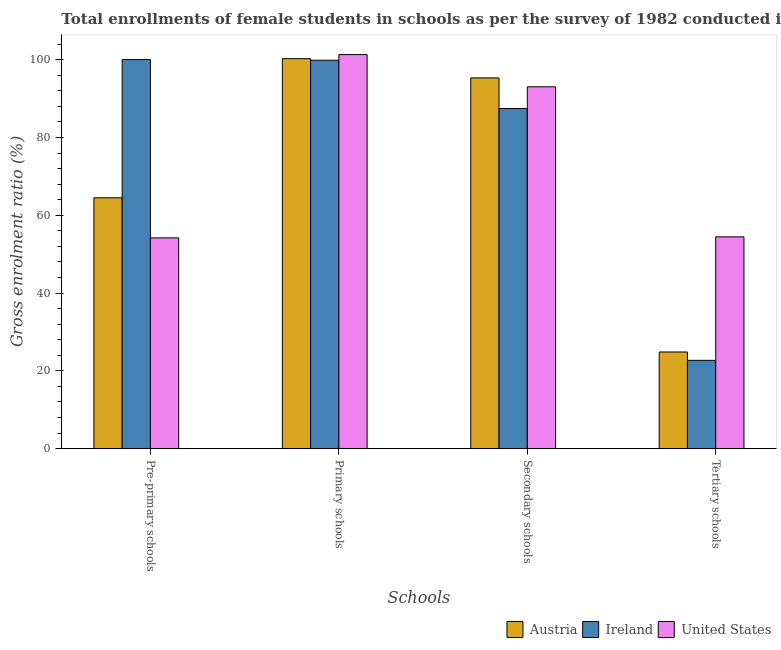How many different coloured bars are there?
Offer a very short reply. 3. How many groups of bars are there?
Your response must be concise. 4. How many bars are there on the 3rd tick from the left?
Your response must be concise. 3. How many bars are there on the 3rd tick from the right?
Ensure brevity in your answer.  3. What is the label of the 1st group of bars from the left?
Offer a very short reply. Pre-primary schools. What is the gross enrolment ratio(female) in tertiary schools in Ireland?
Offer a very short reply. 22.71. Across all countries, what is the maximum gross enrolment ratio(female) in secondary schools?
Provide a short and direct response. 95.3. Across all countries, what is the minimum gross enrolment ratio(female) in secondary schools?
Offer a very short reply. 87.44. In which country was the gross enrolment ratio(female) in primary schools maximum?
Your answer should be very brief. United States. In which country was the gross enrolment ratio(female) in tertiary schools minimum?
Your response must be concise. Ireland. What is the total gross enrolment ratio(female) in pre-primary schools in the graph?
Keep it short and to the point. 218.69. What is the difference between the gross enrolment ratio(female) in primary schools in Austria and that in Ireland?
Provide a succinct answer. 0.41. What is the difference between the gross enrolment ratio(female) in primary schools in Ireland and the gross enrolment ratio(female) in pre-primary schools in United States?
Your response must be concise. 45.66. What is the average gross enrolment ratio(female) in pre-primary schools per country?
Provide a short and direct response. 72.9. What is the difference between the gross enrolment ratio(female) in pre-primary schools and gross enrolment ratio(female) in secondary schools in United States?
Ensure brevity in your answer.  -38.84. What is the ratio of the gross enrolment ratio(female) in secondary schools in Ireland to that in Austria?
Your answer should be compact. 0.92. Is the gross enrolment ratio(female) in secondary schools in Ireland less than that in United States?
Offer a terse response. Yes. What is the difference between the highest and the second highest gross enrolment ratio(female) in pre-primary schools?
Ensure brevity in your answer.  35.52. What is the difference between the highest and the lowest gross enrolment ratio(female) in primary schools?
Offer a very short reply. 1.46. Is the sum of the gross enrolment ratio(female) in pre-primary schools in Austria and United States greater than the maximum gross enrolment ratio(female) in tertiary schools across all countries?
Provide a succinct answer. Yes. What does the 2nd bar from the left in Tertiary schools represents?
Provide a succinct answer. Ireland. What does the 1st bar from the right in Secondary schools represents?
Your answer should be compact. United States. Where does the legend appear in the graph?
Give a very brief answer. Bottom right. How many legend labels are there?
Give a very brief answer. 3. How are the legend labels stacked?
Make the answer very short. Horizontal. What is the title of the graph?
Your answer should be very brief. Total enrollments of female students in schools as per the survey of 1982 conducted in different countries. Does "Benin" appear as one of the legend labels in the graph?
Ensure brevity in your answer.  No. What is the label or title of the X-axis?
Offer a very short reply. Schools. What is the Gross enrolment ratio (%) of Austria in Pre-primary schools?
Give a very brief answer. 64.49. What is the Gross enrolment ratio (%) in Ireland in Pre-primary schools?
Your answer should be compact. 100.01. What is the Gross enrolment ratio (%) of United States in Pre-primary schools?
Offer a terse response. 54.18. What is the Gross enrolment ratio (%) of Austria in Primary schools?
Provide a short and direct response. 100.24. What is the Gross enrolment ratio (%) in Ireland in Primary schools?
Offer a terse response. 99.84. What is the Gross enrolment ratio (%) in United States in Primary schools?
Ensure brevity in your answer.  101.3. What is the Gross enrolment ratio (%) in Austria in Secondary schools?
Provide a succinct answer. 95.3. What is the Gross enrolment ratio (%) of Ireland in Secondary schools?
Offer a very short reply. 87.44. What is the Gross enrolment ratio (%) of United States in Secondary schools?
Provide a short and direct response. 93.02. What is the Gross enrolment ratio (%) of Austria in Tertiary schools?
Your answer should be very brief. 24.85. What is the Gross enrolment ratio (%) of Ireland in Tertiary schools?
Make the answer very short. 22.71. What is the Gross enrolment ratio (%) in United States in Tertiary schools?
Your answer should be compact. 54.45. Across all Schools, what is the maximum Gross enrolment ratio (%) of Austria?
Keep it short and to the point. 100.24. Across all Schools, what is the maximum Gross enrolment ratio (%) in Ireland?
Make the answer very short. 100.01. Across all Schools, what is the maximum Gross enrolment ratio (%) of United States?
Make the answer very short. 101.3. Across all Schools, what is the minimum Gross enrolment ratio (%) in Austria?
Your answer should be compact. 24.85. Across all Schools, what is the minimum Gross enrolment ratio (%) of Ireland?
Your response must be concise. 22.71. Across all Schools, what is the minimum Gross enrolment ratio (%) in United States?
Keep it short and to the point. 54.18. What is the total Gross enrolment ratio (%) of Austria in the graph?
Make the answer very short. 284.89. What is the total Gross enrolment ratio (%) in Ireland in the graph?
Your answer should be very brief. 310. What is the total Gross enrolment ratio (%) of United States in the graph?
Provide a succinct answer. 302.95. What is the difference between the Gross enrolment ratio (%) of Austria in Pre-primary schools and that in Primary schools?
Offer a terse response. -35.75. What is the difference between the Gross enrolment ratio (%) in Ireland in Pre-primary schools and that in Primary schools?
Your response must be concise. 0.17. What is the difference between the Gross enrolment ratio (%) in United States in Pre-primary schools and that in Primary schools?
Keep it short and to the point. -47.12. What is the difference between the Gross enrolment ratio (%) in Austria in Pre-primary schools and that in Secondary schools?
Provide a succinct answer. -30.81. What is the difference between the Gross enrolment ratio (%) of Ireland in Pre-primary schools and that in Secondary schools?
Ensure brevity in your answer.  12.57. What is the difference between the Gross enrolment ratio (%) in United States in Pre-primary schools and that in Secondary schools?
Your response must be concise. -38.84. What is the difference between the Gross enrolment ratio (%) in Austria in Pre-primary schools and that in Tertiary schools?
Keep it short and to the point. 39.64. What is the difference between the Gross enrolment ratio (%) of Ireland in Pre-primary schools and that in Tertiary schools?
Offer a terse response. 77.31. What is the difference between the Gross enrolment ratio (%) of United States in Pre-primary schools and that in Tertiary schools?
Make the answer very short. -0.27. What is the difference between the Gross enrolment ratio (%) in Austria in Primary schools and that in Secondary schools?
Keep it short and to the point. 4.94. What is the difference between the Gross enrolment ratio (%) of Ireland in Primary schools and that in Secondary schools?
Give a very brief answer. 12.4. What is the difference between the Gross enrolment ratio (%) of United States in Primary schools and that in Secondary schools?
Your response must be concise. 8.28. What is the difference between the Gross enrolment ratio (%) in Austria in Primary schools and that in Tertiary schools?
Offer a very short reply. 75.39. What is the difference between the Gross enrolment ratio (%) in Ireland in Primary schools and that in Tertiary schools?
Give a very brief answer. 77.13. What is the difference between the Gross enrolment ratio (%) of United States in Primary schools and that in Tertiary schools?
Ensure brevity in your answer.  46.85. What is the difference between the Gross enrolment ratio (%) of Austria in Secondary schools and that in Tertiary schools?
Your response must be concise. 70.45. What is the difference between the Gross enrolment ratio (%) in Ireland in Secondary schools and that in Tertiary schools?
Ensure brevity in your answer.  64.73. What is the difference between the Gross enrolment ratio (%) in United States in Secondary schools and that in Tertiary schools?
Make the answer very short. 38.57. What is the difference between the Gross enrolment ratio (%) of Austria in Pre-primary schools and the Gross enrolment ratio (%) of Ireland in Primary schools?
Offer a very short reply. -35.35. What is the difference between the Gross enrolment ratio (%) in Austria in Pre-primary schools and the Gross enrolment ratio (%) in United States in Primary schools?
Your answer should be very brief. -36.81. What is the difference between the Gross enrolment ratio (%) in Ireland in Pre-primary schools and the Gross enrolment ratio (%) in United States in Primary schools?
Offer a very short reply. -1.29. What is the difference between the Gross enrolment ratio (%) of Austria in Pre-primary schools and the Gross enrolment ratio (%) of Ireland in Secondary schools?
Provide a short and direct response. -22.95. What is the difference between the Gross enrolment ratio (%) of Austria in Pre-primary schools and the Gross enrolment ratio (%) of United States in Secondary schools?
Make the answer very short. -28.53. What is the difference between the Gross enrolment ratio (%) of Ireland in Pre-primary schools and the Gross enrolment ratio (%) of United States in Secondary schools?
Give a very brief answer. 6.99. What is the difference between the Gross enrolment ratio (%) of Austria in Pre-primary schools and the Gross enrolment ratio (%) of Ireland in Tertiary schools?
Your answer should be compact. 41.78. What is the difference between the Gross enrolment ratio (%) in Austria in Pre-primary schools and the Gross enrolment ratio (%) in United States in Tertiary schools?
Give a very brief answer. 10.04. What is the difference between the Gross enrolment ratio (%) of Ireland in Pre-primary schools and the Gross enrolment ratio (%) of United States in Tertiary schools?
Offer a terse response. 45.57. What is the difference between the Gross enrolment ratio (%) in Austria in Primary schools and the Gross enrolment ratio (%) in Ireland in Secondary schools?
Offer a very short reply. 12.8. What is the difference between the Gross enrolment ratio (%) in Austria in Primary schools and the Gross enrolment ratio (%) in United States in Secondary schools?
Your response must be concise. 7.22. What is the difference between the Gross enrolment ratio (%) of Ireland in Primary schools and the Gross enrolment ratio (%) of United States in Secondary schools?
Give a very brief answer. 6.82. What is the difference between the Gross enrolment ratio (%) of Austria in Primary schools and the Gross enrolment ratio (%) of Ireland in Tertiary schools?
Offer a terse response. 77.54. What is the difference between the Gross enrolment ratio (%) in Austria in Primary schools and the Gross enrolment ratio (%) in United States in Tertiary schools?
Offer a terse response. 45.8. What is the difference between the Gross enrolment ratio (%) of Ireland in Primary schools and the Gross enrolment ratio (%) of United States in Tertiary schools?
Give a very brief answer. 45.39. What is the difference between the Gross enrolment ratio (%) of Austria in Secondary schools and the Gross enrolment ratio (%) of Ireland in Tertiary schools?
Give a very brief answer. 72.59. What is the difference between the Gross enrolment ratio (%) of Austria in Secondary schools and the Gross enrolment ratio (%) of United States in Tertiary schools?
Keep it short and to the point. 40.86. What is the difference between the Gross enrolment ratio (%) of Ireland in Secondary schools and the Gross enrolment ratio (%) of United States in Tertiary schools?
Provide a short and direct response. 32.99. What is the average Gross enrolment ratio (%) of Austria per Schools?
Give a very brief answer. 71.22. What is the average Gross enrolment ratio (%) of Ireland per Schools?
Provide a short and direct response. 77.5. What is the average Gross enrolment ratio (%) in United States per Schools?
Offer a terse response. 75.74. What is the difference between the Gross enrolment ratio (%) of Austria and Gross enrolment ratio (%) of Ireland in Pre-primary schools?
Your answer should be compact. -35.52. What is the difference between the Gross enrolment ratio (%) of Austria and Gross enrolment ratio (%) of United States in Pre-primary schools?
Keep it short and to the point. 10.31. What is the difference between the Gross enrolment ratio (%) of Ireland and Gross enrolment ratio (%) of United States in Pre-primary schools?
Offer a very short reply. 45.83. What is the difference between the Gross enrolment ratio (%) in Austria and Gross enrolment ratio (%) in Ireland in Primary schools?
Provide a succinct answer. 0.41. What is the difference between the Gross enrolment ratio (%) of Austria and Gross enrolment ratio (%) of United States in Primary schools?
Keep it short and to the point. -1.06. What is the difference between the Gross enrolment ratio (%) of Ireland and Gross enrolment ratio (%) of United States in Primary schools?
Offer a terse response. -1.46. What is the difference between the Gross enrolment ratio (%) in Austria and Gross enrolment ratio (%) in Ireland in Secondary schools?
Keep it short and to the point. 7.86. What is the difference between the Gross enrolment ratio (%) in Austria and Gross enrolment ratio (%) in United States in Secondary schools?
Make the answer very short. 2.28. What is the difference between the Gross enrolment ratio (%) of Ireland and Gross enrolment ratio (%) of United States in Secondary schools?
Provide a succinct answer. -5.58. What is the difference between the Gross enrolment ratio (%) of Austria and Gross enrolment ratio (%) of Ireland in Tertiary schools?
Give a very brief answer. 2.15. What is the difference between the Gross enrolment ratio (%) of Austria and Gross enrolment ratio (%) of United States in Tertiary schools?
Offer a terse response. -29.59. What is the difference between the Gross enrolment ratio (%) in Ireland and Gross enrolment ratio (%) in United States in Tertiary schools?
Ensure brevity in your answer.  -31.74. What is the ratio of the Gross enrolment ratio (%) in Austria in Pre-primary schools to that in Primary schools?
Your response must be concise. 0.64. What is the ratio of the Gross enrolment ratio (%) in United States in Pre-primary schools to that in Primary schools?
Offer a very short reply. 0.53. What is the ratio of the Gross enrolment ratio (%) of Austria in Pre-primary schools to that in Secondary schools?
Your response must be concise. 0.68. What is the ratio of the Gross enrolment ratio (%) of Ireland in Pre-primary schools to that in Secondary schools?
Give a very brief answer. 1.14. What is the ratio of the Gross enrolment ratio (%) in United States in Pre-primary schools to that in Secondary schools?
Offer a very short reply. 0.58. What is the ratio of the Gross enrolment ratio (%) in Austria in Pre-primary schools to that in Tertiary schools?
Offer a terse response. 2.59. What is the ratio of the Gross enrolment ratio (%) of Ireland in Pre-primary schools to that in Tertiary schools?
Make the answer very short. 4.4. What is the ratio of the Gross enrolment ratio (%) of Austria in Primary schools to that in Secondary schools?
Keep it short and to the point. 1.05. What is the ratio of the Gross enrolment ratio (%) in Ireland in Primary schools to that in Secondary schools?
Provide a short and direct response. 1.14. What is the ratio of the Gross enrolment ratio (%) in United States in Primary schools to that in Secondary schools?
Provide a short and direct response. 1.09. What is the ratio of the Gross enrolment ratio (%) of Austria in Primary schools to that in Tertiary schools?
Your answer should be very brief. 4.03. What is the ratio of the Gross enrolment ratio (%) in Ireland in Primary schools to that in Tertiary schools?
Your response must be concise. 4.4. What is the ratio of the Gross enrolment ratio (%) of United States in Primary schools to that in Tertiary schools?
Your answer should be very brief. 1.86. What is the ratio of the Gross enrolment ratio (%) of Austria in Secondary schools to that in Tertiary schools?
Give a very brief answer. 3.83. What is the ratio of the Gross enrolment ratio (%) in Ireland in Secondary schools to that in Tertiary schools?
Ensure brevity in your answer.  3.85. What is the ratio of the Gross enrolment ratio (%) of United States in Secondary schools to that in Tertiary schools?
Give a very brief answer. 1.71. What is the difference between the highest and the second highest Gross enrolment ratio (%) in Austria?
Offer a very short reply. 4.94. What is the difference between the highest and the second highest Gross enrolment ratio (%) in Ireland?
Keep it short and to the point. 0.17. What is the difference between the highest and the second highest Gross enrolment ratio (%) in United States?
Your answer should be very brief. 8.28. What is the difference between the highest and the lowest Gross enrolment ratio (%) of Austria?
Your answer should be very brief. 75.39. What is the difference between the highest and the lowest Gross enrolment ratio (%) of Ireland?
Offer a terse response. 77.31. What is the difference between the highest and the lowest Gross enrolment ratio (%) of United States?
Keep it short and to the point. 47.12. 